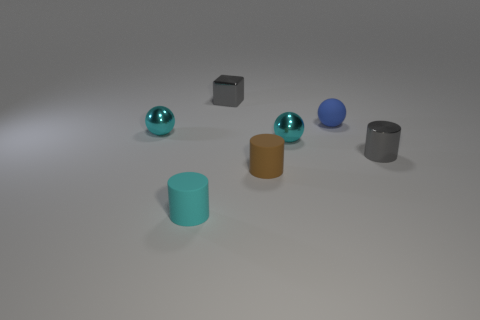Subtract all tiny shiny spheres. How many spheres are left? 1 Subtract all purple cubes. How many cyan balls are left? 2 Add 3 large brown blocks. How many objects exist? 10 Subtract all green balls. Subtract all brown cylinders. How many balls are left? 3 Subtract all balls. How many objects are left? 4 Subtract all tiny blue rubber things. Subtract all big rubber cubes. How many objects are left? 6 Add 2 gray cylinders. How many gray cylinders are left? 3 Add 5 small cyan metallic spheres. How many small cyan metallic spheres exist? 7 Subtract 0 blue cylinders. How many objects are left? 7 